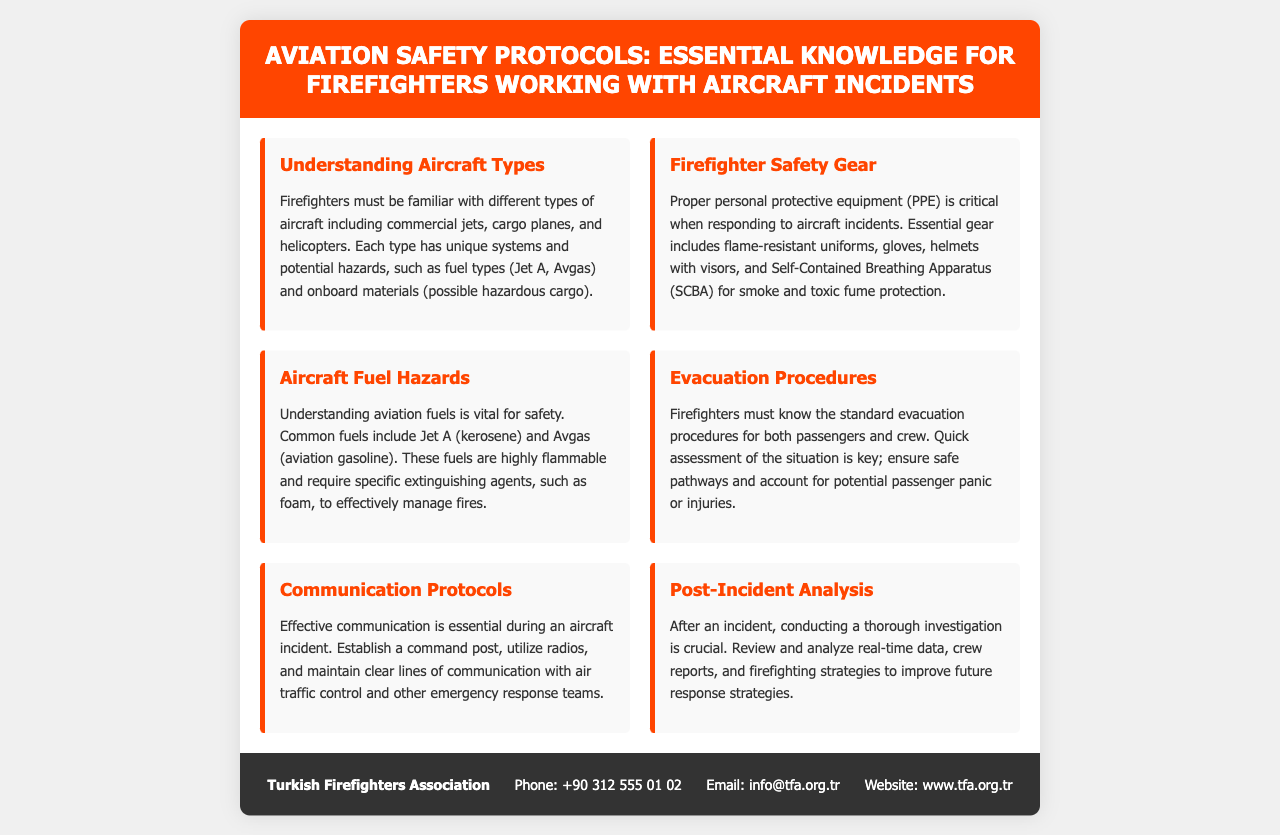What is the title of the brochure? The title of the brochure can be found at the top section of the document.
Answer: Aviation Safety Protocols: Essential Knowledge for Firefighters Working with Aircraft Incidents What type of fuels should firefighters understand? The document provides information about aviation fuels in the section called "Aircraft Fuel Hazards".
Answer: Jet A and Avgas What kind of protective gear is mentioned as essential? The section on Firefighter Safety Gear outlines the necessary protective equipment.
Answer: Flame-resistant uniforms What is a key responsibility during an aircraft incident? The section on Evacuation Procedures details critical actions firefighters must take.
Answer: Quick assessment of the situation What protocol is emphasized for effective communication? The Communication Protocols section elaborates on the necessity of establishing a command post.
Answer: Establish a command post How often should post-incident analysis be conducted? The document implies the importance of conducting thorough investigations after every incident.
Answer: After every incident Which organization is mentioned at the bottom of the document? The footer provides contact information for the organization associated with the brochure.
Answer: Turkish Firefighters Association How can firefighters protect themselves from smoke? The Firefighter Safety Gear section mentions a specific equipment type for protection against smoke.
Answer: Self-Contained Breathing Apparatus (SCBA) 